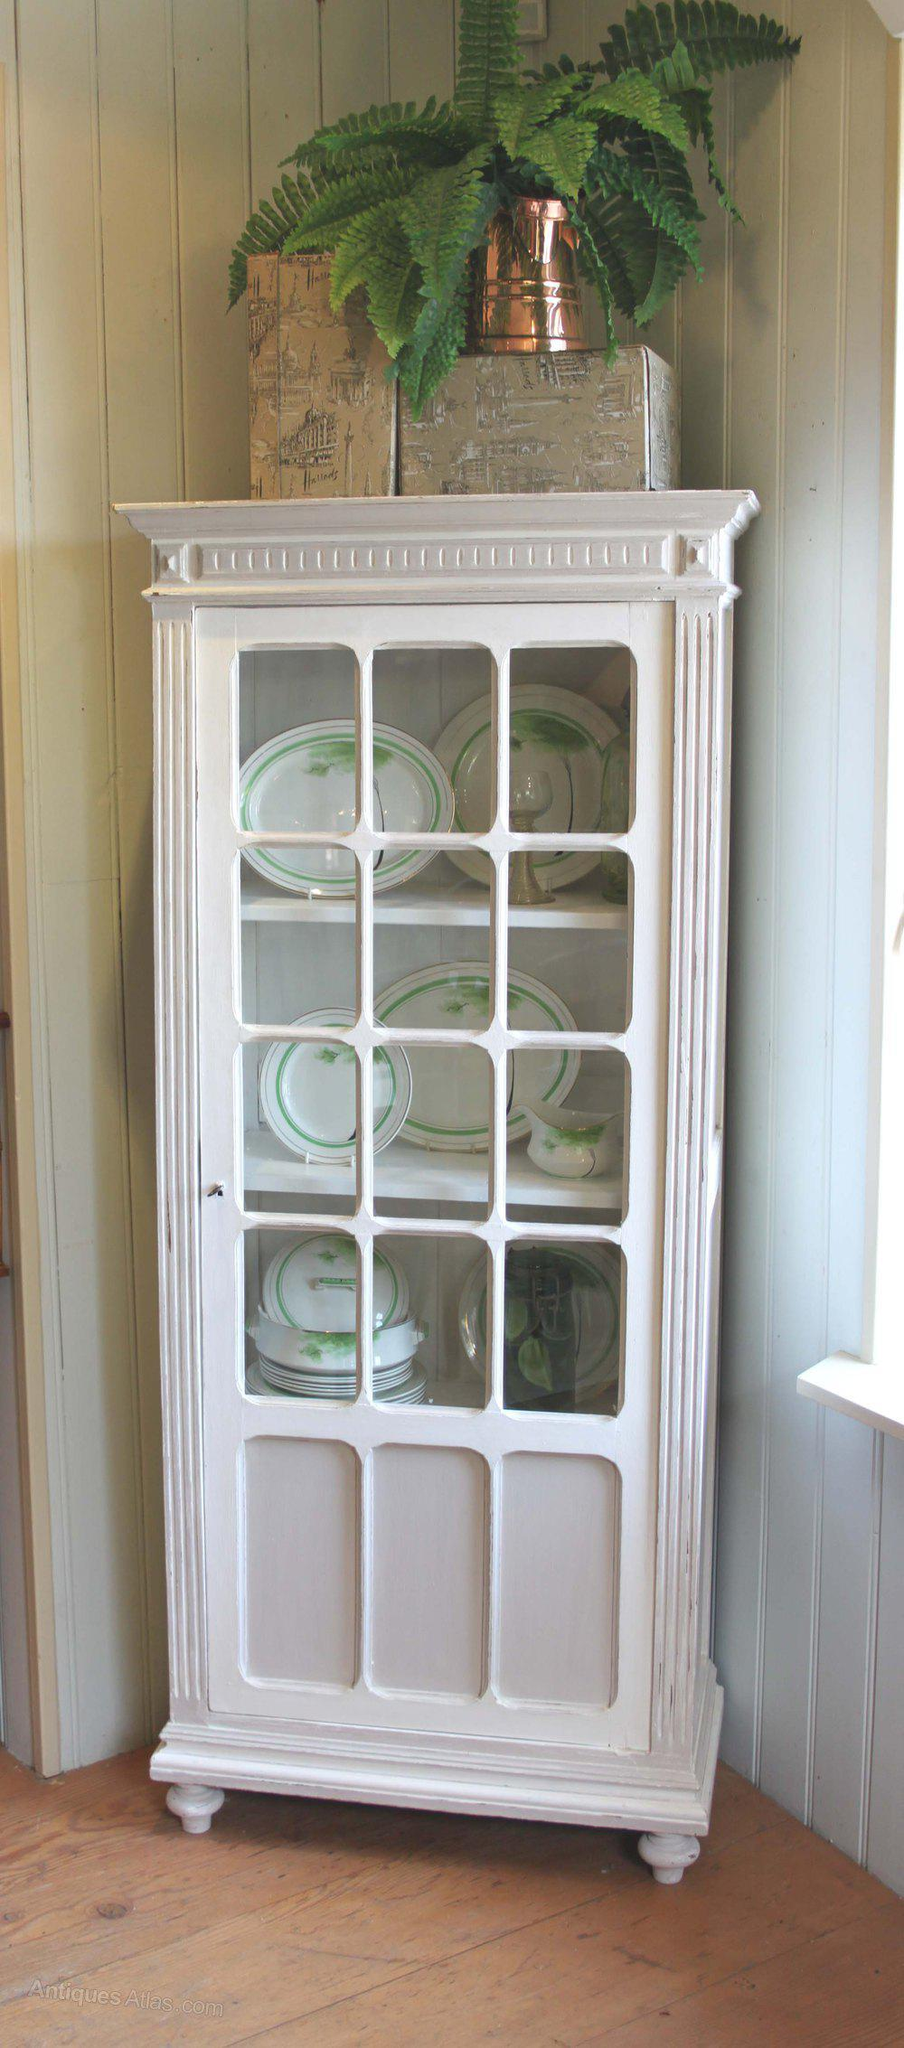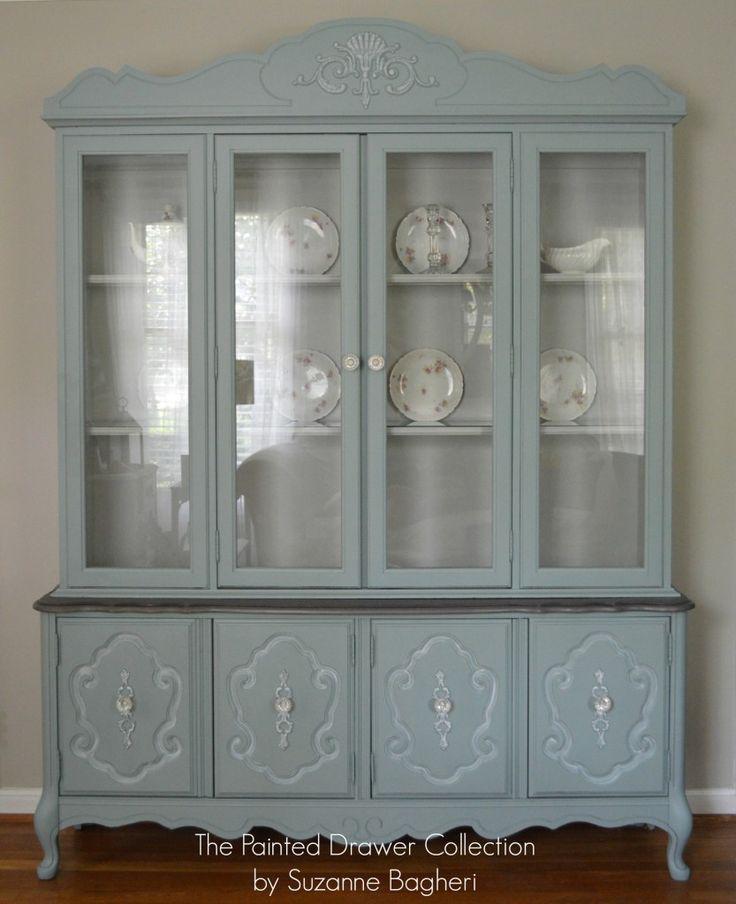The first image is the image on the left, the second image is the image on the right. Considering the images on both sides, is "Two painted hutches are different widths, with one sitting flush to the floor and the other with open space above the floor." valid? Answer yes or no. No. The first image is the image on the left, the second image is the image on the right. Given the left and right images, does the statement "A blue hutch in one image has four glass doors and four lower panel doors, and is wider than a white hutch with glass doors in the second image." hold true? Answer yes or no. Yes. The first image is the image on the left, the second image is the image on the right. Considering the images on both sides, is "One cabinet has a curved top with a fleur-de-lis design, and scrollwork at the footed base." valid? Answer yes or no. Yes. 